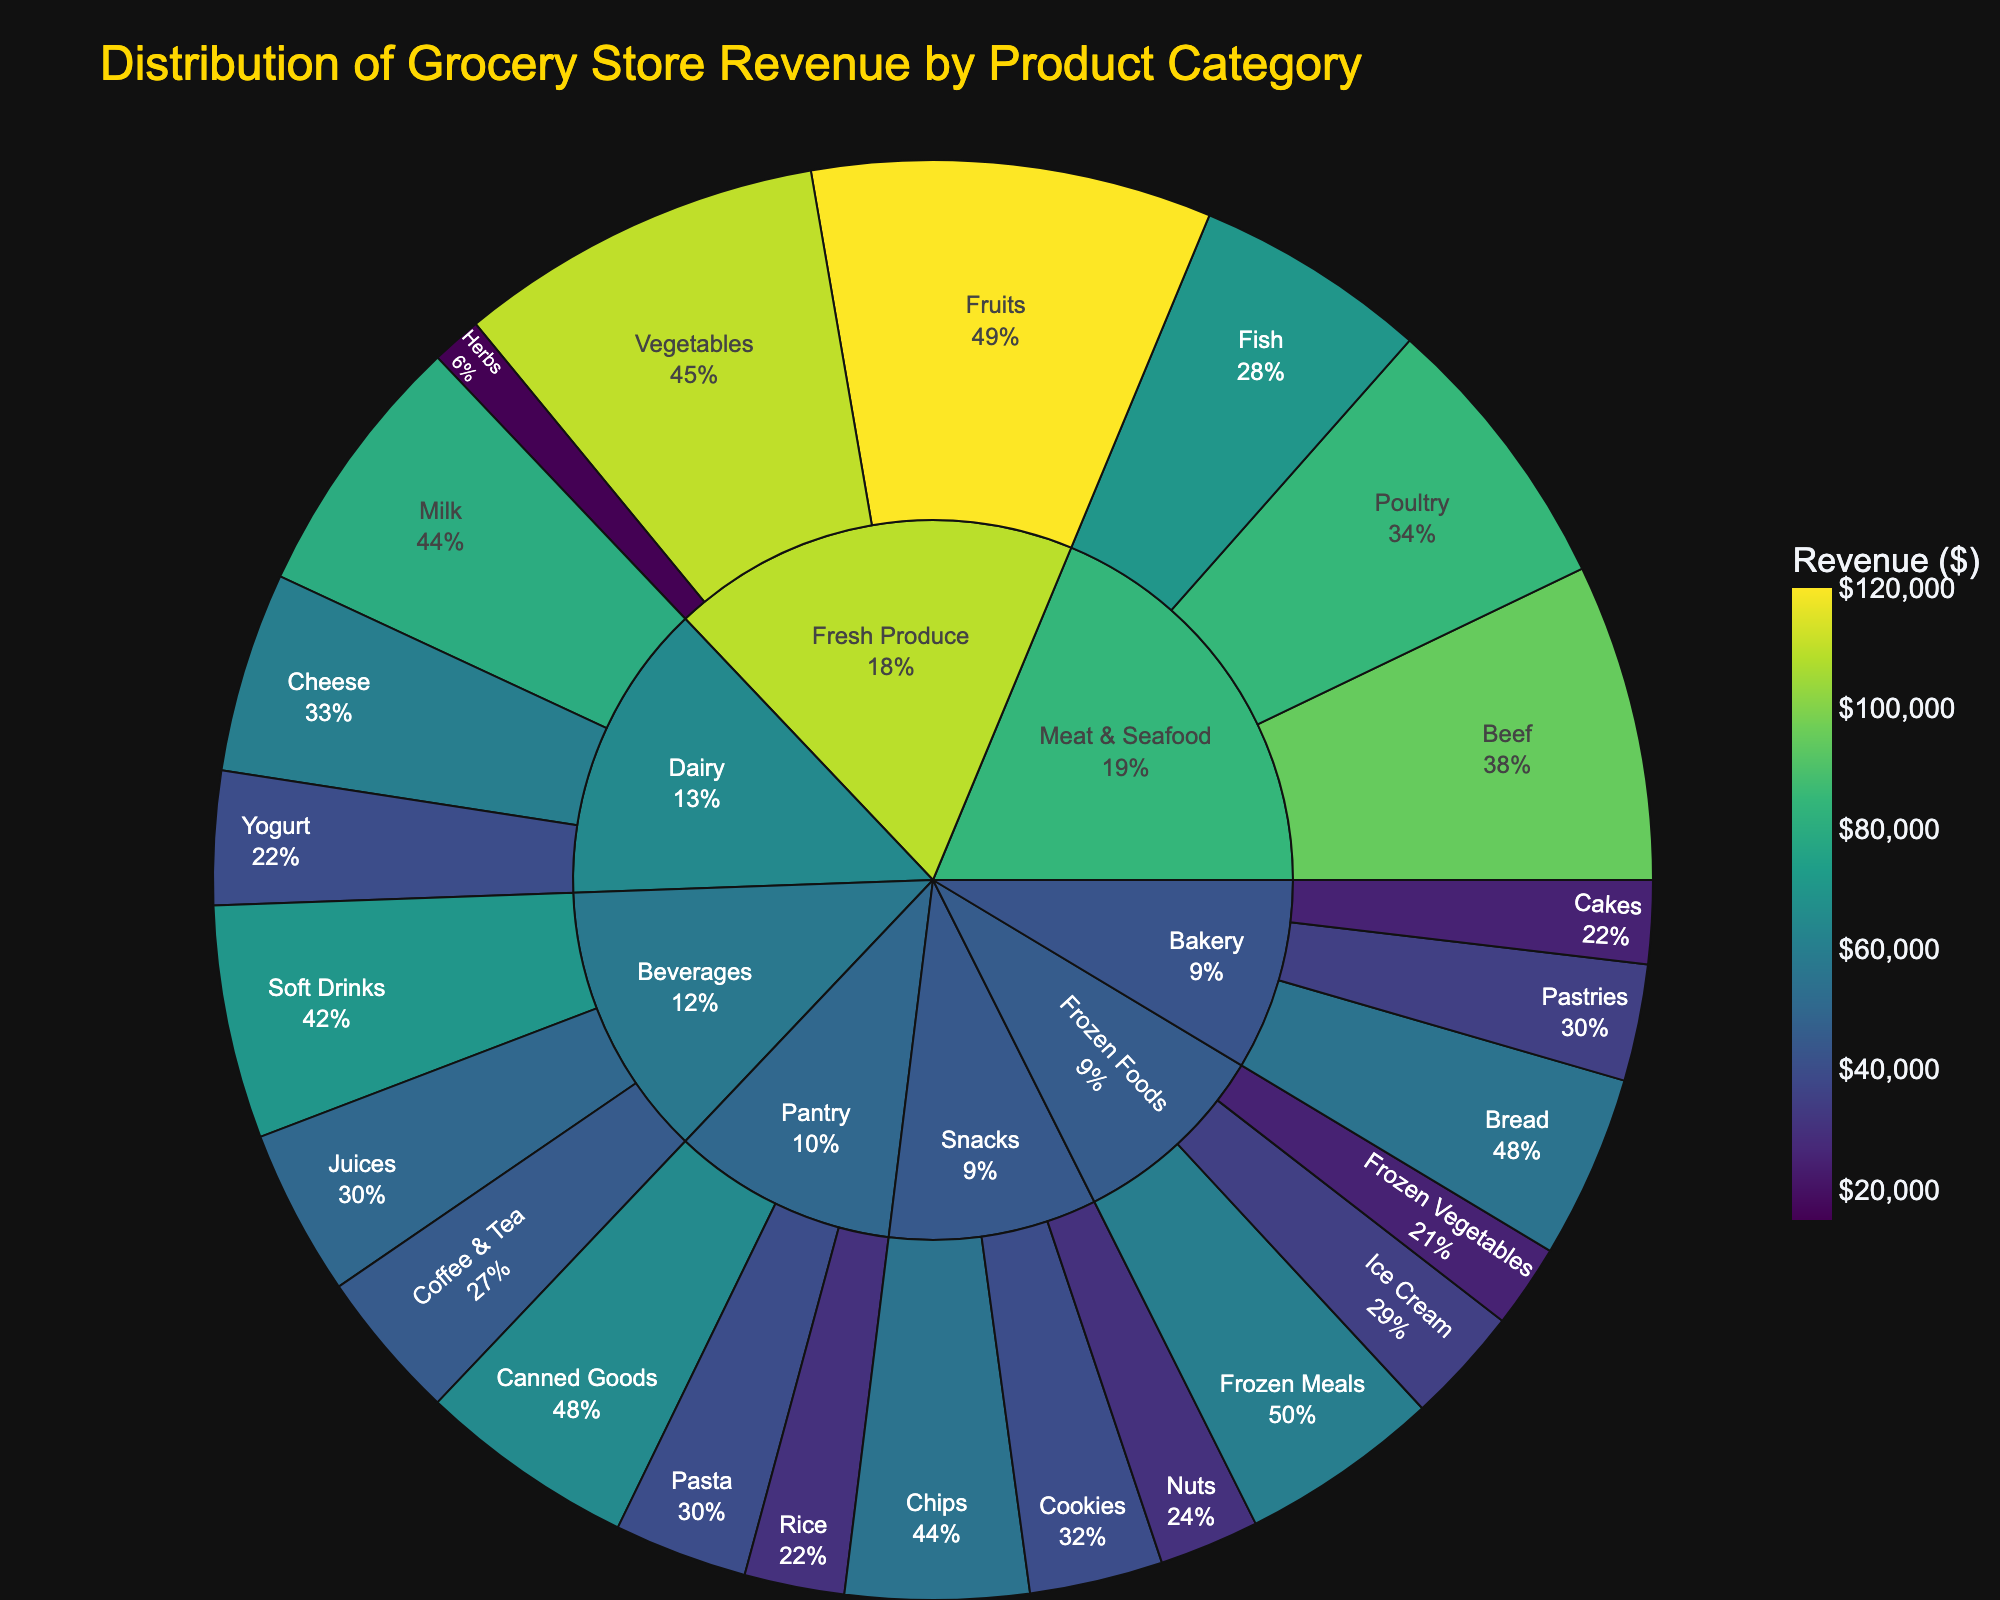Which product category generates the highest revenue? By looking at the largest section in the sunburst plot, we see that "Fresh Produce" is the category with the highest revenue.
Answer: Fresh Produce What is the total revenue generated by the Dairy category? The sunburst plot shows breakdowns of revenue by product subcategories. Summing the revenues for Milk ($80,000), Cheese ($60,000), and Yogurt ($40,000) gives $80,000 + $60,000 + $40,000.
Answer: $180,000 Which subcategory within Beverages earns more revenue: Soft Drinks or Juices? The plot indicates that Soft Drinks have a revenue of $70,000 and Juices have a revenue of $50,000. Comparing these, Soft Drinks have higher revenue.
Answer: Soft Drinks How does the revenue of Meat & Seafood compare to Bakery? To compare, sum up the individual revenues: Meat & Seafood (Beef $95,000 + Poultry $85,000 + Fish $70,000 = $250,000), Bakery (Bread $55,000 + Pastries $35,000 + Cakes $25,000 = $115,000).
Answer: Meat & Seafood ($250,000) is greater than Bakery ($115,000) What is the revenue contribution of Frozen Foods to the total store revenue? The revenue segments within Frozen Foods (Frozen Meals $60,000, Ice Cream $35,000, Frozen Vegetables $25,000) together add up to $60,000 + $35,000 + $25,000 = $120,000. The total store revenue is the sum of all categories' revenues, here calculated directly using full data. Frozen Foods' contribution can then be understood as $120,000 out of the grand total.
Answer: $120,000 out of $1,175,000 (about 10.2%) Which subcategory has the lowest revenue in the entire distribution? By checking the smallest segment in the sunburst plot, we see that "Frozen Vegetables" has the lowest revenue.
Answer: Frozen Vegetables Are there more subcategories under the Snacks or Pantry category? Snacks have Chips, Cookies, and Nuts (3 subcategories). Pantry has Canned Goods, Pasta, and Rice (3 subcategories). So, both categories have the same number of subcategories.
Answer: They have the same (3 each) What's the combined revenue of all subcategories under Fresh Produce and Dairy? Summing the revenues of Fresh Produce (Fruits $120,000 + Vegetables $110,000 + Herbs $15,000 = $245,000) and Dairy (Milk $80,000 + Cheese $60,000 + Yogurt $40,000 = $180,000), then adding these sums: $245,000 + $180,000 = $425,000.
Answer: $425,000 Which subcategory within the Meat & Seafood category generates the second highest revenue? Within Meat & Seafood, Beef ($95,000), Poultry ($85,000), and Fish ($70,000). Poultry generates the second highest revenue, just after Beef.
Answer: Poultry In the Bakery category, what is the revenue difference between Bread and Cakes? From the plot, Bread has a revenue of $55,000 and Cakes have $25,000. The difference is $55,000 - $25,000.
Answer: $30,000 